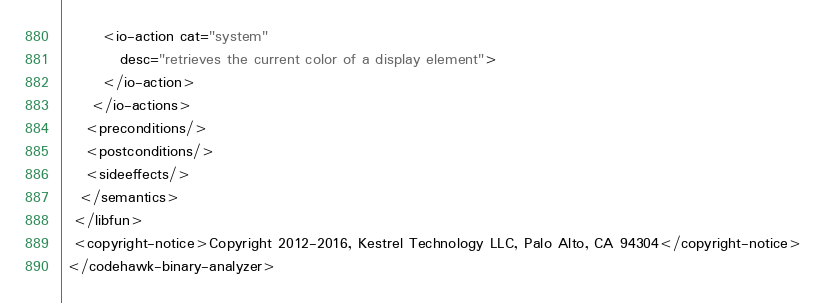Convert code to text. <code><loc_0><loc_0><loc_500><loc_500><_XML_>       <io-action cat="system"
		  desc="retrieves the current color of a display element">
       </io-action>
     </io-actions>
    <preconditions/>
    <postconditions/>
    <sideeffects/>
   </semantics>
  </libfun>
  <copyright-notice>Copyright 2012-2016, Kestrel Technology LLC, Palo Alto, CA 94304</copyright-notice>
 </codehawk-binary-analyzer>
</code> 